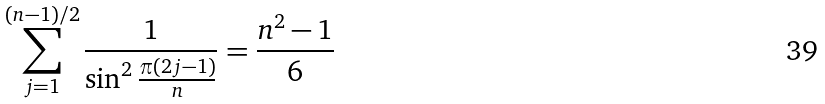Convert formula to latex. <formula><loc_0><loc_0><loc_500><loc_500>\sum _ { j = 1 } ^ { ( n - 1 ) / 2 } \frac { 1 } { \sin ^ { 2 } \frac { \pi ( 2 j - 1 ) } { n } } = \frac { n ^ { 2 } - 1 } { 6 }</formula> 